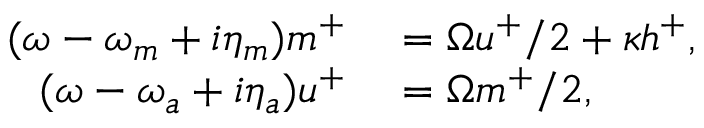Convert formula to latex. <formula><loc_0><loc_0><loc_500><loc_500>\begin{array} { r l } { ( \omega - \omega _ { m } + i \eta _ { m } ) m ^ { + } } & = \Omega u ^ { + } / 2 + \kappa h ^ { + } , } \\ { ( \omega - \omega _ { a } + i \eta _ { a } ) u ^ { + } } & = \Omega m ^ { + } / 2 , } \end{array}</formula> 